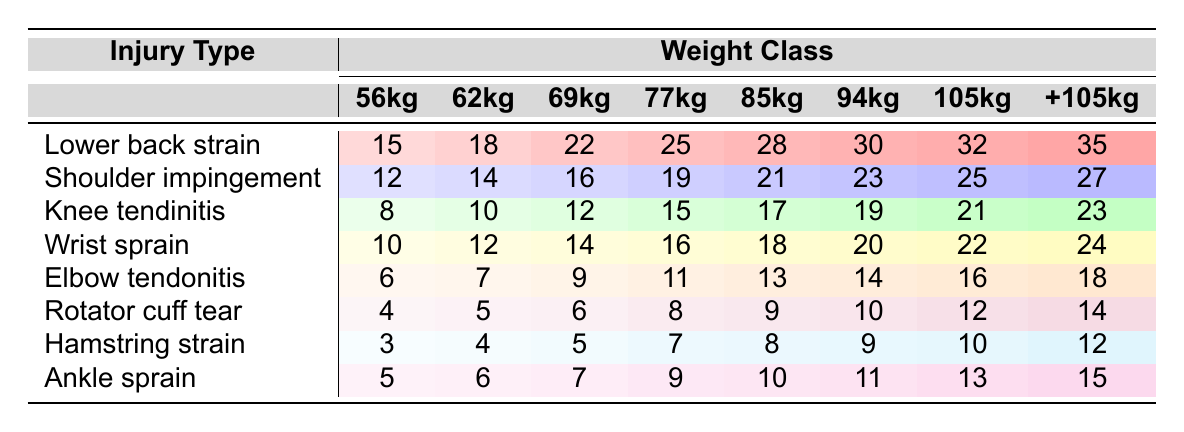What is the prevalence of lower back strain in the 85kg weight class? According to the table, the prevalence of lower back strain in the 85kg weight class is 28.
Answer: 28 Which weight class has the highest number of knee tendinitis cases? The table indicates that the +105kg weight class has the highest number of knee tendinitis cases, totaling 23.
Answer: +105kg How many shoulder impingement cases are reported in the 62kg and 69kg weight classes combined? Adding the total number of shoulder impingement cases for the 62kg (14) and 69kg (16) weight classes gives us 14 + 16 = 30 cases in total.
Answer: 30 Is there a higher prevalence of wrist sprains in the 77kg weight class compared to the 56kg weight class? The table shows that the 77kg weight class has 16 wrist sprains, while the 56kg class has 10. Therefore, 77kg has a higher prevalence of wrist sprains.
Answer: Yes What is the average prevalence of hamstring strains across all weight classes? To find the average, sum the prevalence of hamstring strains (3 + 4 + 5 + 7 + 8 + 9 + 10 + 12 = 58) and divide by the number of weight classes (8). Thus, the average is 58 / 8 = 7.25.
Answer: 7.25 Which injury type has the highest prevalence in the +105kg weight class? The table shows that the +105kg weight class has the highest prevalence of lower back strain (35 cases) as compared to other injury types.
Answer: Lower back strain What is the difference in prevalence of elbow tendonitis between the 94kg and 105kg weight classes? The prevalence of elbow tendonitis in the 94kg class is 14, while in the 105kg class it is 16. The difference is 16 - 14 = 2.
Answer: 2 Can you identify any weight class where knee tendinitis is lower than 10 cases? Examining the table, it is evident that only the 56kg weight class has knee tendinitis lower than 10 cases, with a total of 8.
Answer: Yes What percentage of the total reported injuries does the shoulder impingement account for in the 94kg weight class? The total number of injuries in the 94kg class is 30 (lower back strain 30 + shoulder impingement 23 + ... + ankle sprain 11 = 115). Shoulder impingement has 23 cases. The percentage is (23 / 115) * 100 ≈ 20%.
Answer: Approximately 20% Which weight class has the least number of cases for hamstring strain? The table shows that the 56kg weight class has the least number of cases for hamstring strain, totaling 3.
Answer: 56kg What is the total number of ankle sprains across all weight classes? By summing the prevalence of ankle sprains from all weight classes (5 + 6 + 7 + 9 + 10 + 11 + 13 + 15 = 66), the total number of ankle sprains across all classes is 66.
Answer: 66 